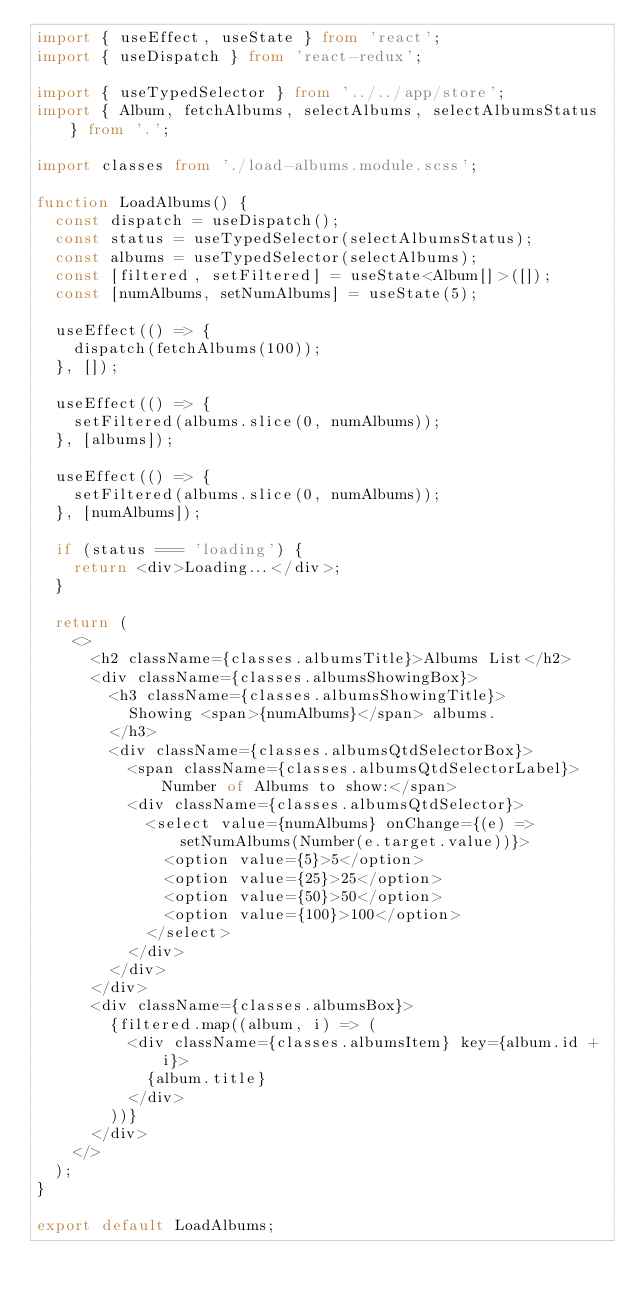<code> <loc_0><loc_0><loc_500><loc_500><_TypeScript_>import { useEffect, useState } from 'react';
import { useDispatch } from 'react-redux';

import { useTypedSelector } from '../../app/store';
import { Album, fetchAlbums, selectAlbums, selectAlbumsStatus } from '.';

import classes from './load-albums.module.scss';

function LoadAlbums() {
  const dispatch = useDispatch();
  const status = useTypedSelector(selectAlbumsStatus);
  const albums = useTypedSelector(selectAlbums);
  const [filtered, setFiltered] = useState<Album[]>([]);
  const [numAlbums, setNumAlbums] = useState(5);

  useEffect(() => {
    dispatch(fetchAlbums(100));
  }, []);

  useEffect(() => {
    setFiltered(albums.slice(0, numAlbums));
  }, [albums]);

  useEffect(() => {
    setFiltered(albums.slice(0, numAlbums));
  }, [numAlbums]);

  if (status === 'loading') {
    return <div>Loading...</div>;
  }

  return (
    <>
      <h2 className={classes.albumsTitle}>Albums List</h2>
      <div className={classes.albumsShowingBox}>
        <h3 className={classes.albumsShowingTitle}>
          Showing <span>{numAlbums}</span> albums.
        </h3>
        <div className={classes.albumsQtdSelectorBox}>
          <span className={classes.albumsQtdSelectorLabel}>Number of Albums to show:</span>
          <div className={classes.albumsQtdSelector}>
            <select value={numAlbums} onChange={(e) => setNumAlbums(Number(e.target.value))}>
              <option value={5}>5</option>
              <option value={25}>25</option>
              <option value={50}>50</option>
              <option value={100}>100</option>
            </select>
          </div>
        </div>
      </div>
      <div className={classes.albumsBox}>
        {filtered.map((album, i) => (
          <div className={classes.albumsItem} key={album.id + i}>
            {album.title}
          </div>
        ))}
      </div>
    </>
  );
}

export default LoadAlbums;
</code> 